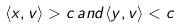Convert formula to latex. <formula><loc_0><loc_0><loc_500><loc_500>\langle x , v \rangle > c \, { a n d } \langle y , v \rangle < c</formula> 